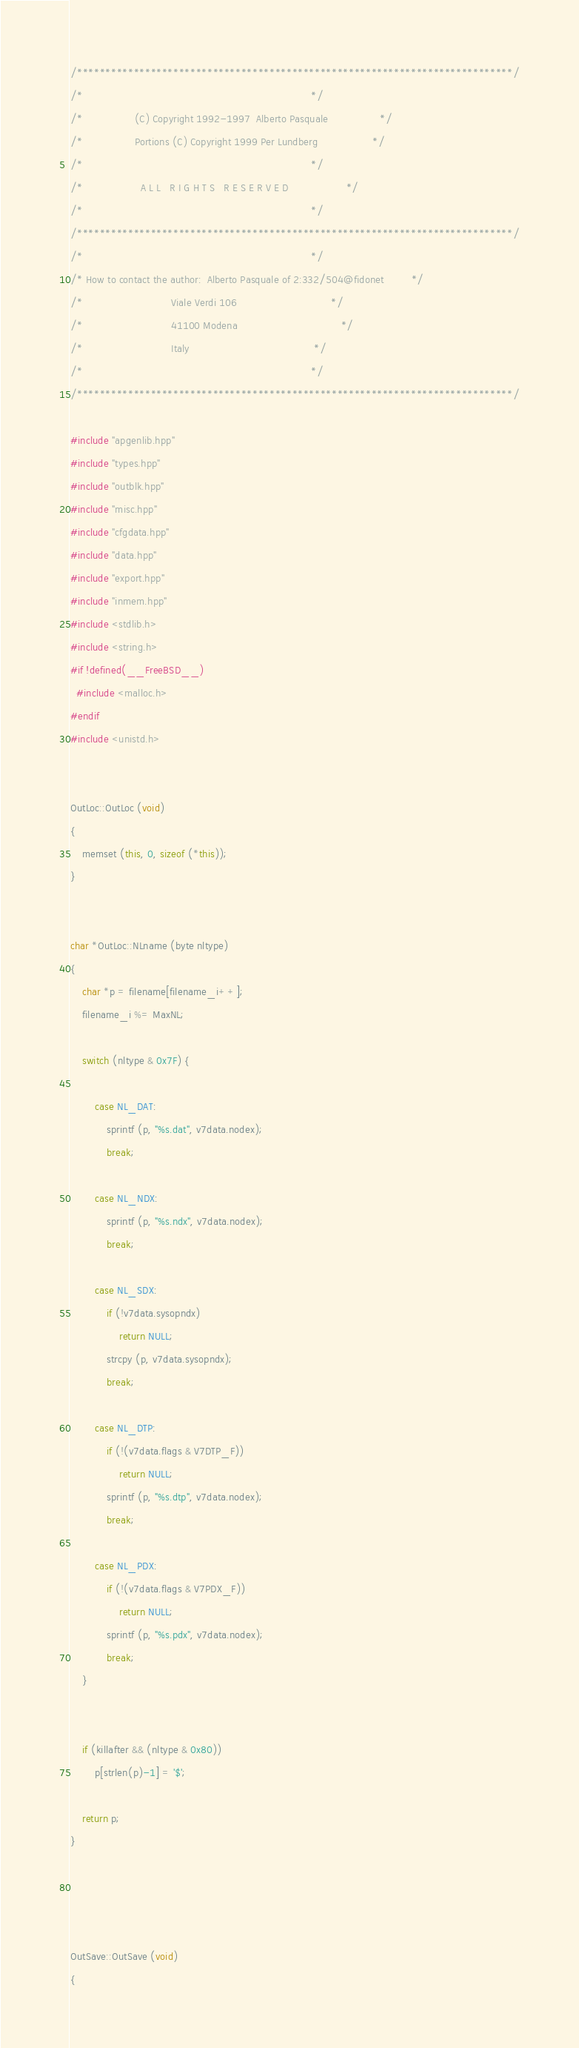Convert code to text. <code><loc_0><loc_0><loc_500><loc_500><_C++_>/*****************************************************************************/
/*                                                                           */
/*                 (C) Copyright 1992-1997  Alberto Pasquale                 */
/*                 Portions (C) Copyright 1999 Per Lundberg                  */
/*                                                                           */
/*                   A L L   R I G H T S   R E S E R V E D                   */
/*                                                                           */
/*****************************************************************************/
/*                                                                           */
/* How to contact the author:  Alberto Pasquale of 2:332/504@fidonet         */
/*                             Viale Verdi 106                               */
/*                             41100 Modena                                  */
/*                             Italy                                         */
/*                                                                           */
/*****************************************************************************/

#include "apgenlib.hpp"
#include "types.hpp"
#include "outblk.hpp"
#include "misc.hpp"
#include "cfgdata.hpp"
#include "data.hpp"
#include "export.hpp"
#include "inmem.hpp"
#include <stdlib.h>
#include <string.h>
#if !defined(__FreeBSD__)
  #include <malloc.h>
#endif
#include <unistd.h>


OutLoc::OutLoc (void)
{
    memset (this, 0, sizeof (*this));
}


char *OutLoc::NLname (byte nltype)
{
    char *p = filename[filename_i++];
    filename_i %= MaxNL;

    switch (nltype & 0x7F) {

        case NL_DAT:
            sprintf (p, "%s.dat", v7data.nodex);
            break;

        case NL_NDX:
            sprintf (p, "%s.ndx", v7data.nodex);
            break;

        case NL_SDX:
            if (!v7data.sysopndx)
                return NULL;
            strcpy (p, v7data.sysopndx);
            break;

        case NL_DTP:
            if (!(v7data.flags & V7DTP_F))
                return NULL;
            sprintf (p, "%s.dtp", v7data.nodex);
            break;

        case NL_PDX:
            if (!(v7data.flags & V7PDX_F))
                return NULL;
            sprintf (p, "%s.pdx", v7data.nodex);
            break;
    }


    if (killafter && (nltype & 0x80))
        p[strlen(p)-1] = '$';

    return p;
}




OutSave::OutSave (void)
{</code> 